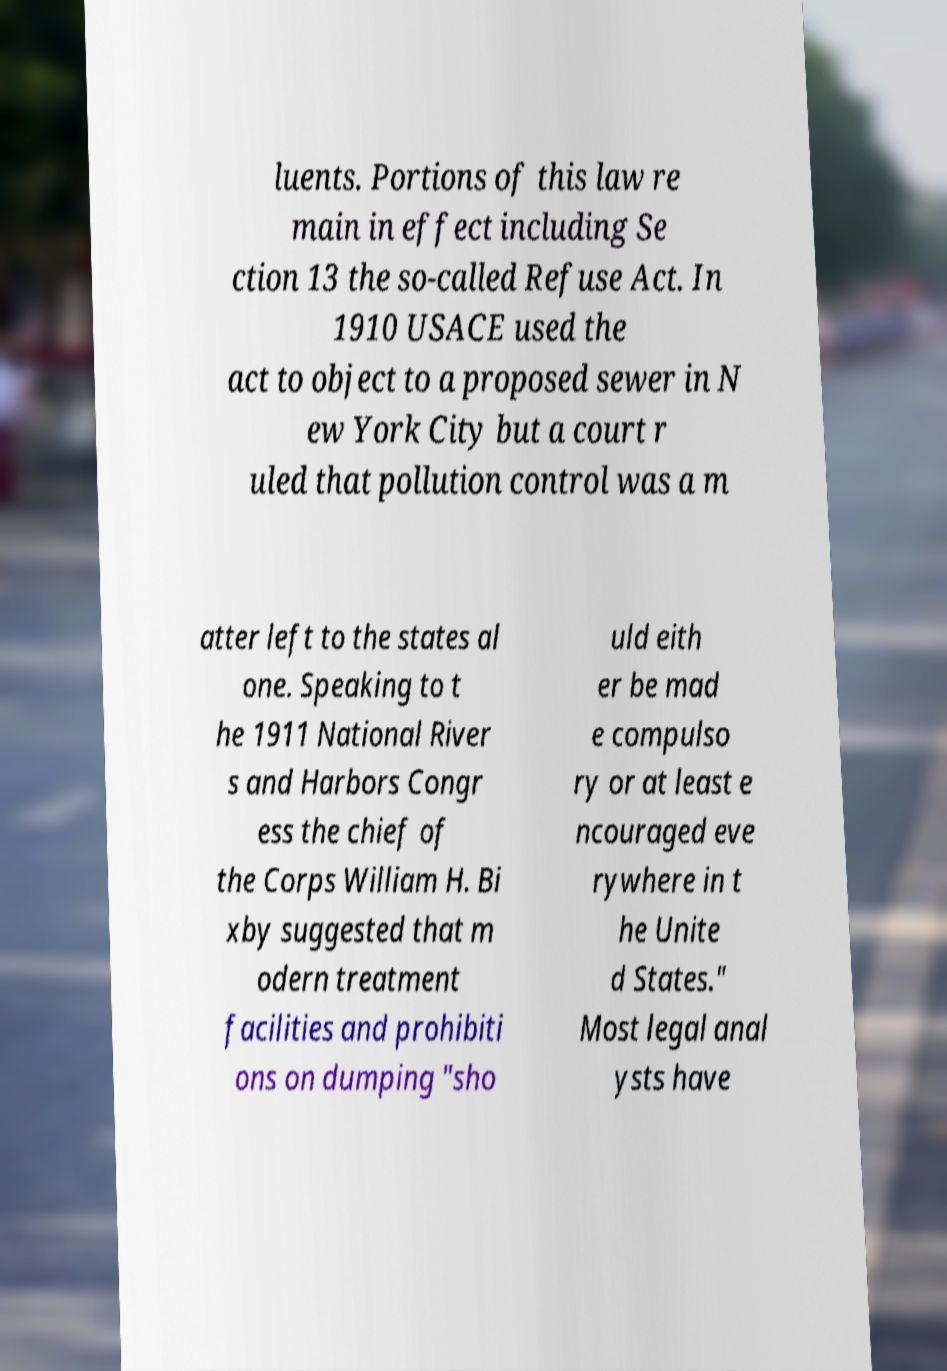Can you accurately transcribe the text from the provided image for me? luents. Portions of this law re main in effect including Se ction 13 the so-called Refuse Act. In 1910 USACE used the act to object to a proposed sewer in N ew York City but a court r uled that pollution control was a m atter left to the states al one. Speaking to t he 1911 National River s and Harbors Congr ess the chief of the Corps William H. Bi xby suggested that m odern treatment facilities and prohibiti ons on dumping "sho uld eith er be mad e compulso ry or at least e ncouraged eve rywhere in t he Unite d States." Most legal anal ysts have 